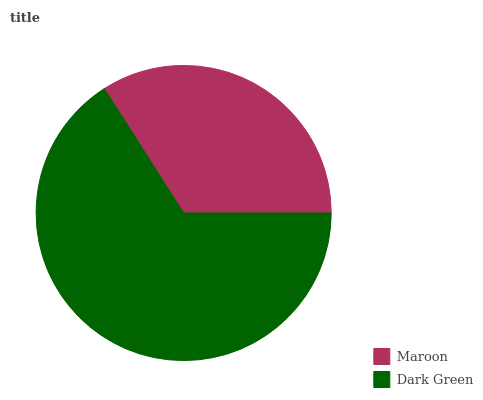Is Maroon the minimum?
Answer yes or no. Yes. Is Dark Green the maximum?
Answer yes or no. Yes. Is Dark Green the minimum?
Answer yes or no. No. Is Dark Green greater than Maroon?
Answer yes or no. Yes. Is Maroon less than Dark Green?
Answer yes or no. Yes. Is Maroon greater than Dark Green?
Answer yes or no. No. Is Dark Green less than Maroon?
Answer yes or no. No. Is Dark Green the high median?
Answer yes or no. Yes. Is Maroon the low median?
Answer yes or no. Yes. Is Maroon the high median?
Answer yes or no. No. Is Dark Green the low median?
Answer yes or no. No. 